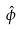Convert formula to latex. <formula><loc_0><loc_0><loc_500><loc_500>\hat { \phi }</formula> 